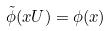<formula> <loc_0><loc_0><loc_500><loc_500>\tilde { \phi } ( x U ) = \phi ( x )</formula> 